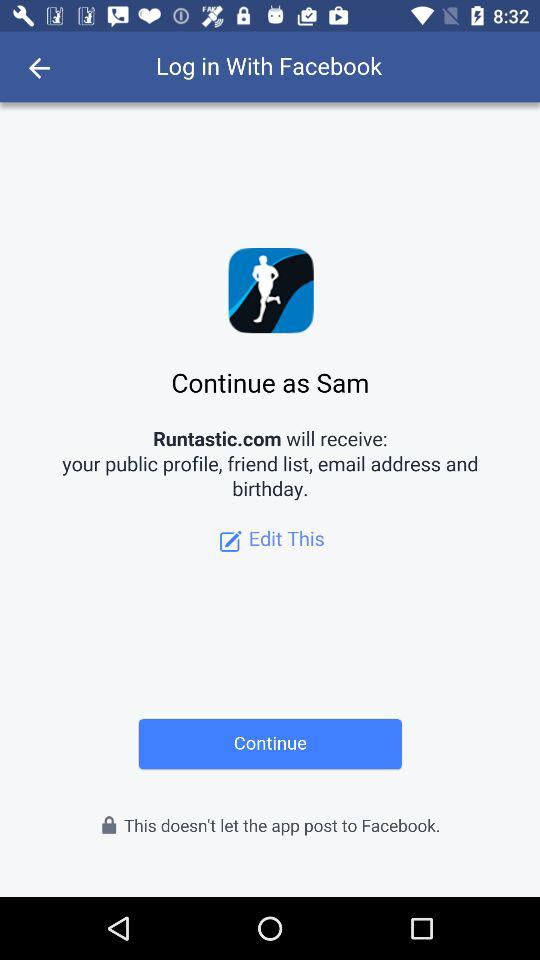What is the name of the user? The name of the user is Sam. 